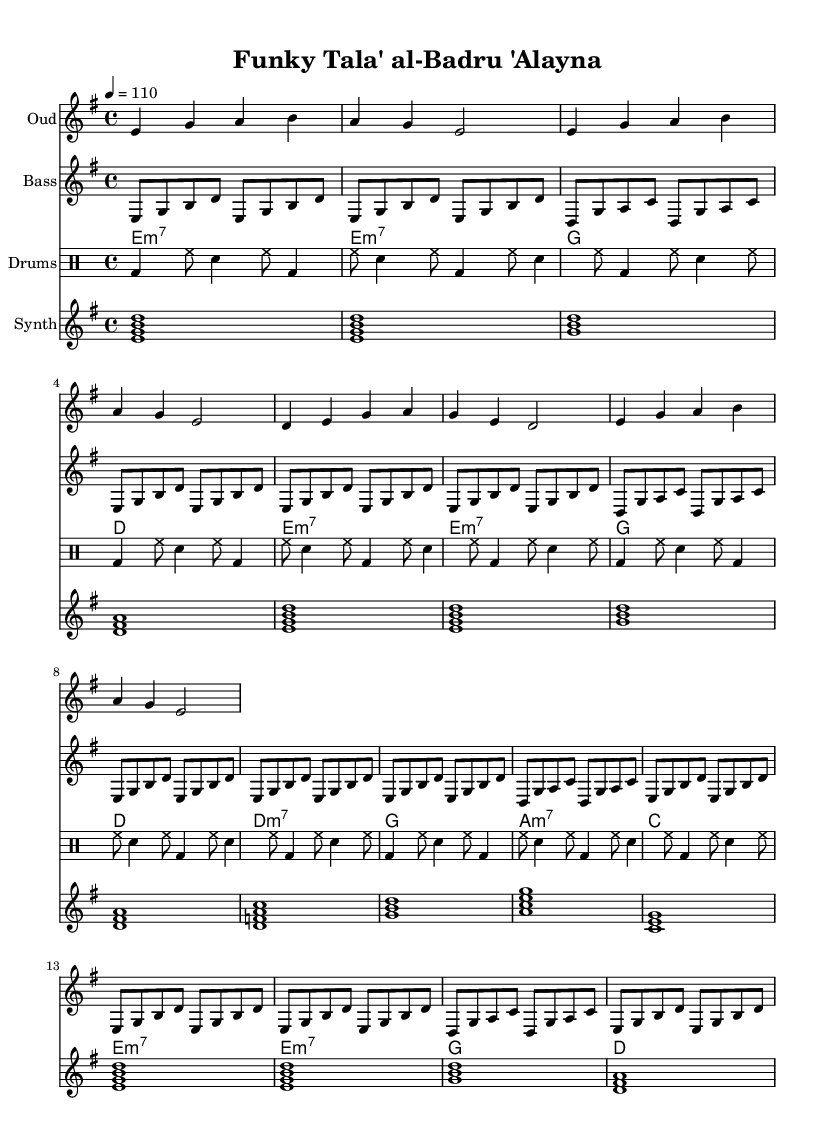What is the key signature of this music? The key signature is indicated at the beginning of the music and shows the notes that are sharp or flat. In this case, it is E minor, which has one sharp (F#) and is represented by the key signature.
Answer: E minor What is the time signature of this music? The time signature, found near the beginning, indicates how many beats are in each measure. Here, it is 4/4, which means there are four beats in each measure and the quarter note gets one beat.
Answer: 4/4 What is the tempo marking for this piece? The tempo marking indicated in the music states the speed at which it should be played. It shows "4 = 110," which means to play four beats per minute at 110 beats per minute.
Answer: 110 How many measures are present in the oud part? By counting the repeated sections in the oud part, we notice that there are four measures repeated multiple times. The repetition structure allows for this easy identification.
Answer: 4 What instrument is playing the bass line? The bass line is identified by its staff with the caption "Bass." It is instrumental in creating the rhythmic foundation typical in funk music, which is heavily based on grooves.
Answer: Bass Which type of chords is used in the electric guitar part? The electric guitar part uses m7 chords, indicated by the notation in the chord segment. This stylistic choice contributes to the funk sound by providing a jazzy harmony.
Answer: m7 What rhythmic pattern is present in the drum section? The drum section contains a specified pattern repeated throughout, consisting of bass drum, hi-hat, and snare drum in a structured repeated format, which is characteristic of funk music grooves.
Answer: BD HH SN 